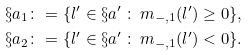Convert formula to latex. <formula><loc_0><loc_0><loc_500><loc_500>\S a _ { 1 } & \colon = \{ l ^ { \prime } \in \S a ^ { \prime } \, \colon \, m _ { - , 1 } ( l ^ { \prime } ) \geq 0 \} , \\ \S a _ { 2 } & \colon = \{ l ^ { \prime } \in \S a ^ { \prime } \, \colon \, m _ { - , 1 } ( l ^ { \prime } ) < 0 \} .</formula> 